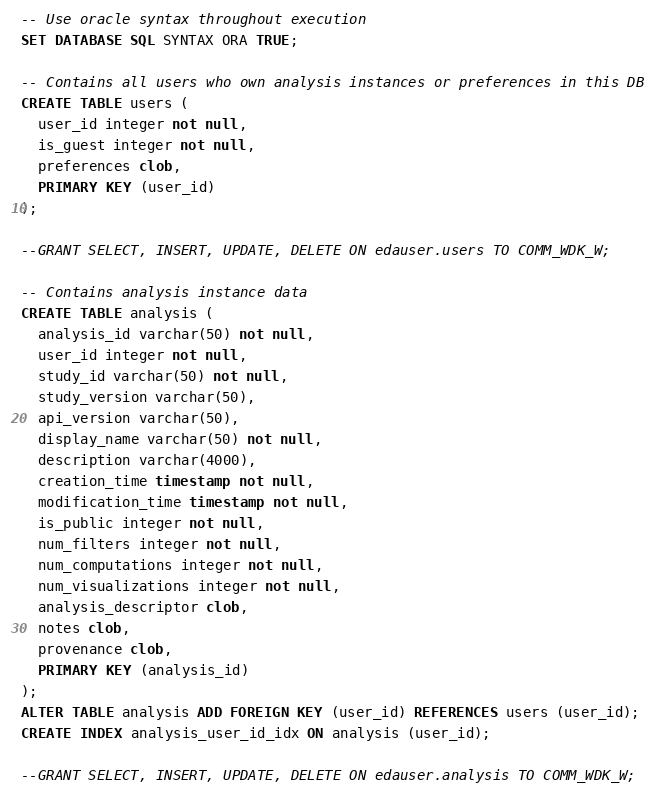<code> <loc_0><loc_0><loc_500><loc_500><_SQL_>-- Use oracle syntax throughout execution
SET DATABASE SQL SYNTAX ORA TRUE;

-- Contains all users who own analysis instances or preferences in this DB
CREATE TABLE users (
  user_id integer not null,
  is_guest integer not null,
  preferences clob,
  PRIMARY KEY (user_id)
);

--GRANT SELECT, INSERT, UPDATE, DELETE ON edauser.users TO COMM_WDK_W;

-- Contains analysis instance data
CREATE TABLE analysis (
  analysis_id varchar(50) not null,
  user_id integer not null,
  study_id varchar(50) not null,
  study_version varchar(50),
  api_version varchar(50),
  display_name varchar(50) not null,
  description varchar(4000),
  creation_time timestamp not null,
  modification_time timestamp not null,
  is_public integer not null,
  num_filters integer not null,
  num_computations integer not null,
  num_visualizations integer not null,
  analysis_descriptor clob,
  notes clob,
  provenance clob,
  PRIMARY KEY (analysis_id)
);
ALTER TABLE analysis ADD FOREIGN KEY (user_id) REFERENCES users (user_id);
CREATE INDEX analysis_user_id_idx ON analysis (user_id);

--GRANT SELECT, INSERT, UPDATE, DELETE ON edauser.analysis TO COMM_WDK_W;
</code> 